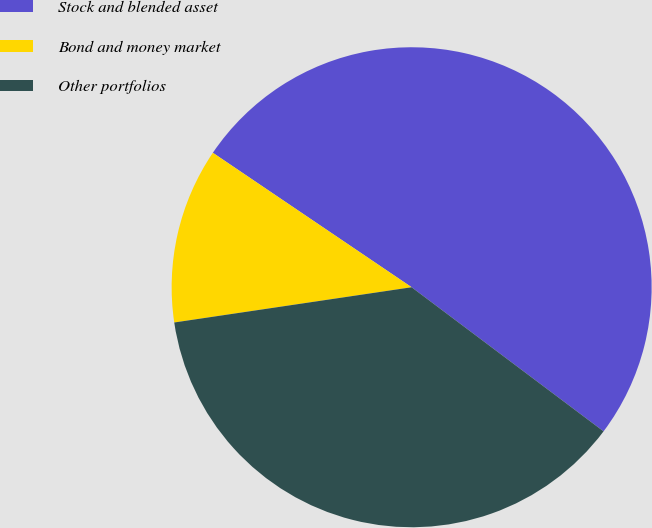Convert chart. <chart><loc_0><loc_0><loc_500><loc_500><pie_chart><fcel>Stock and blended asset<fcel>Bond and money market<fcel>Other portfolios<nl><fcel>50.78%<fcel>11.81%<fcel>37.4%<nl></chart> 